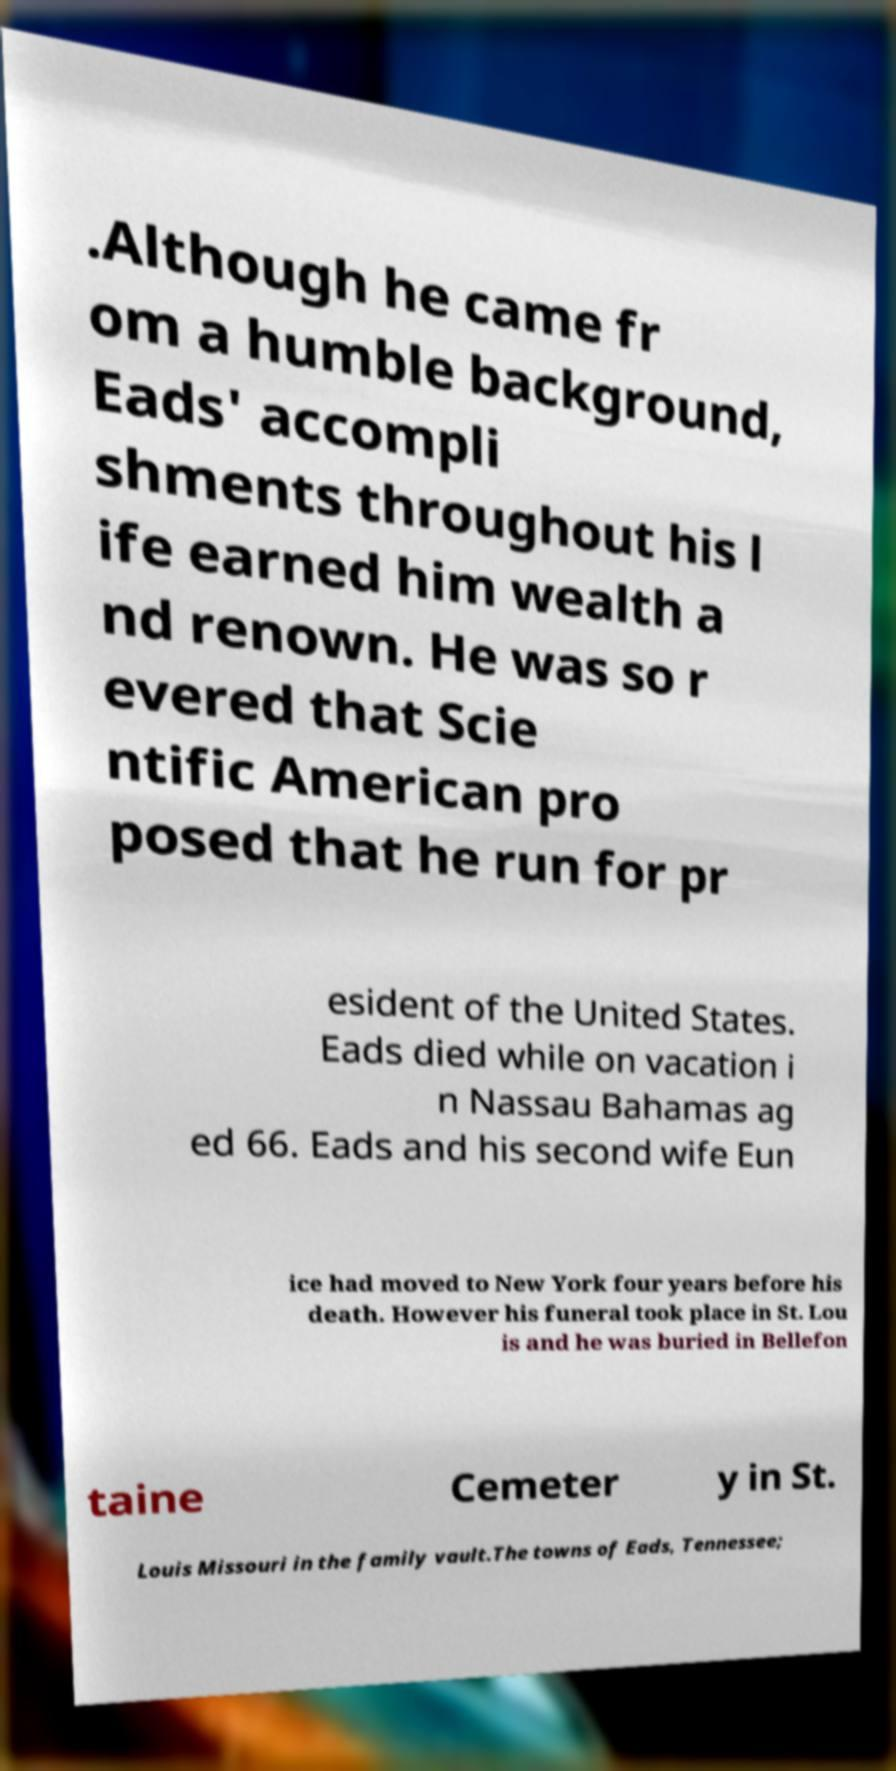Could you assist in decoding the text presented in this image and type it out clearly? .Although he came fr om a humble background, Eads' accompli shments throughout his l ife earned him wealth a nd renown. He was so r evered that Scie ntific American pro posed that he run for pr esident of the United States. Eads died while on vacation i n Nassau Bahamas ag ed 66. Eads and his second wife Eun ice had moved to New York four years before his death. However his funeral took place in St. Lou is and he was buried in Bellefon taine Cemeter y in St. Louis Missouri in the family vault.The towns of Eads, Tennessee; 